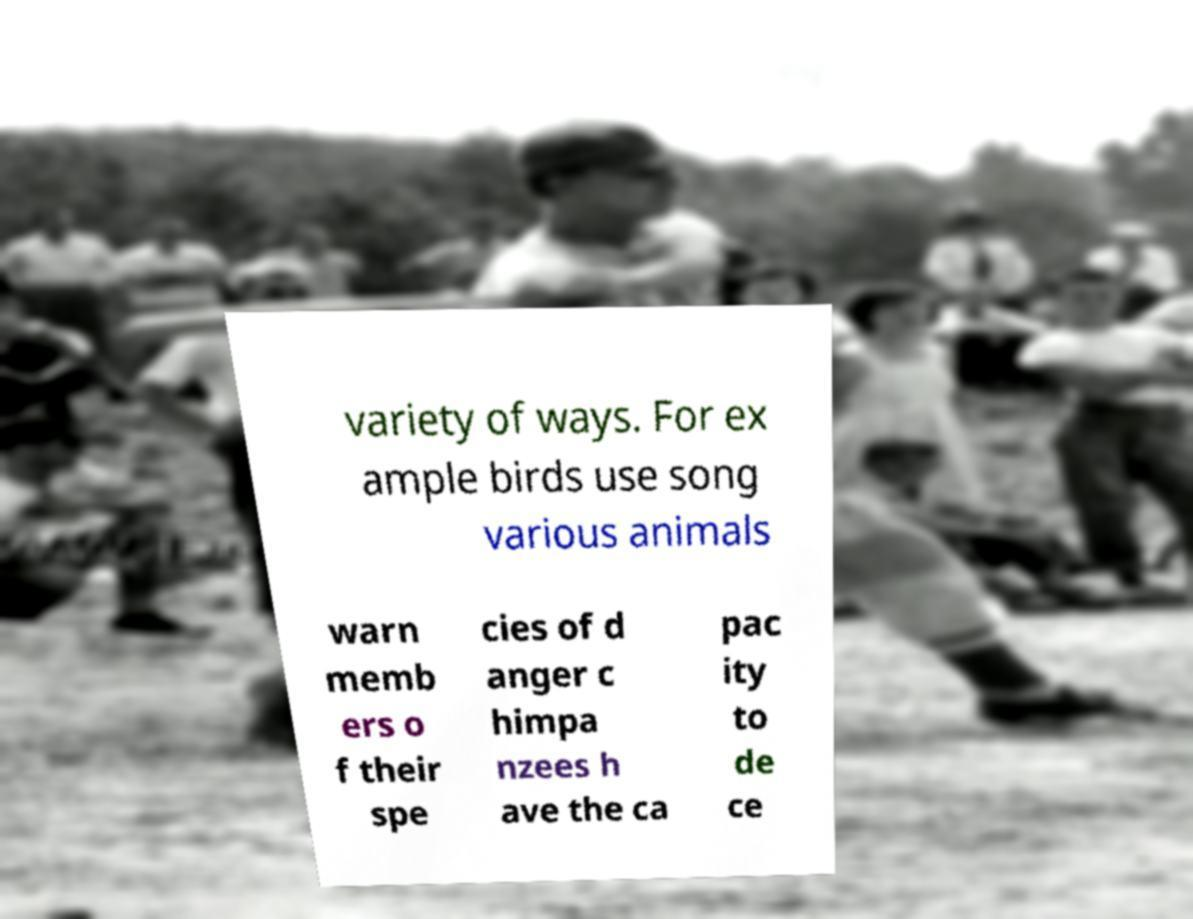Please identify and transcribe the text found in this image. variety of ways. For ex ample birds use song various animals warn memb ers o f their spe cies of d anger c himpa nzees h ave the ca pac ity to de ce 